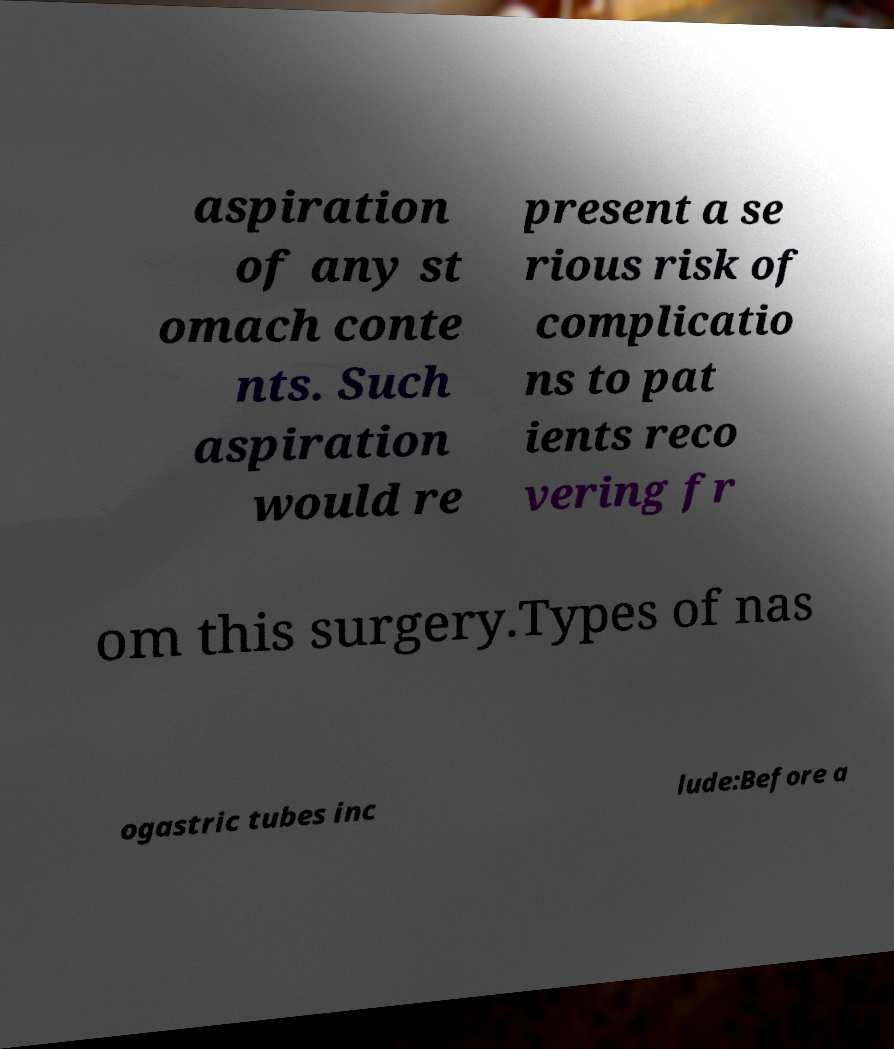For documentation purposes, I need the text within this image transcribed. Could you provide that? aspiration of any st omach conte nts. Such aspiration would re present a se rious risk of complicatio ns to pat ients reco vering fr om this surgery.Types of nas ogastric tubes inc lude:Before a 